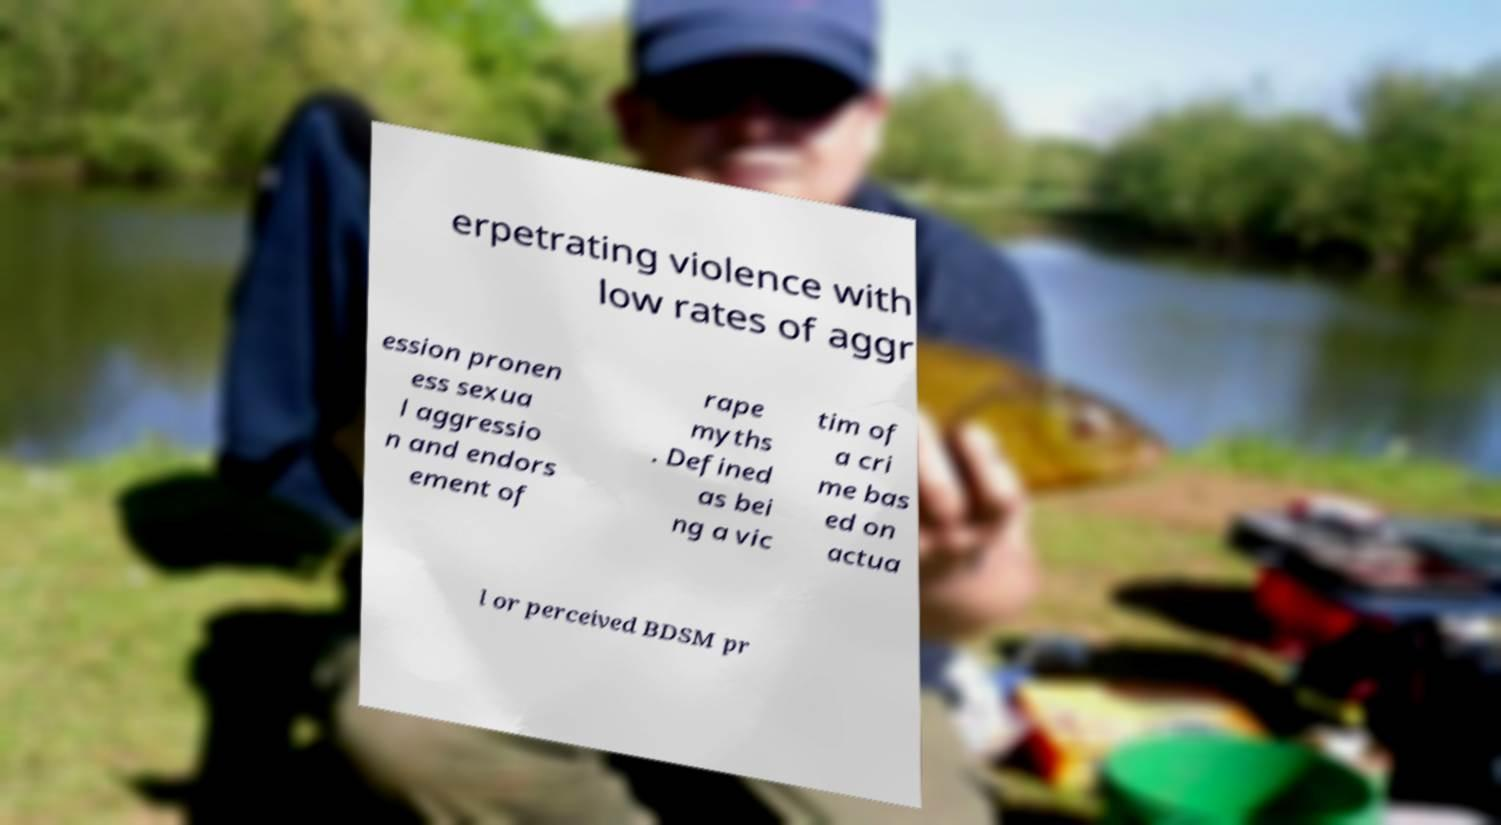I need the written content from this picture converted into text. Can you do that? erpetrating violence with low rates of aggr ession pronen ess sexua l aggressio n and endors ement of rape myths . Defined as bei ng a vic tim of a cri me bas ed on actua l or perceived BDSM pr 